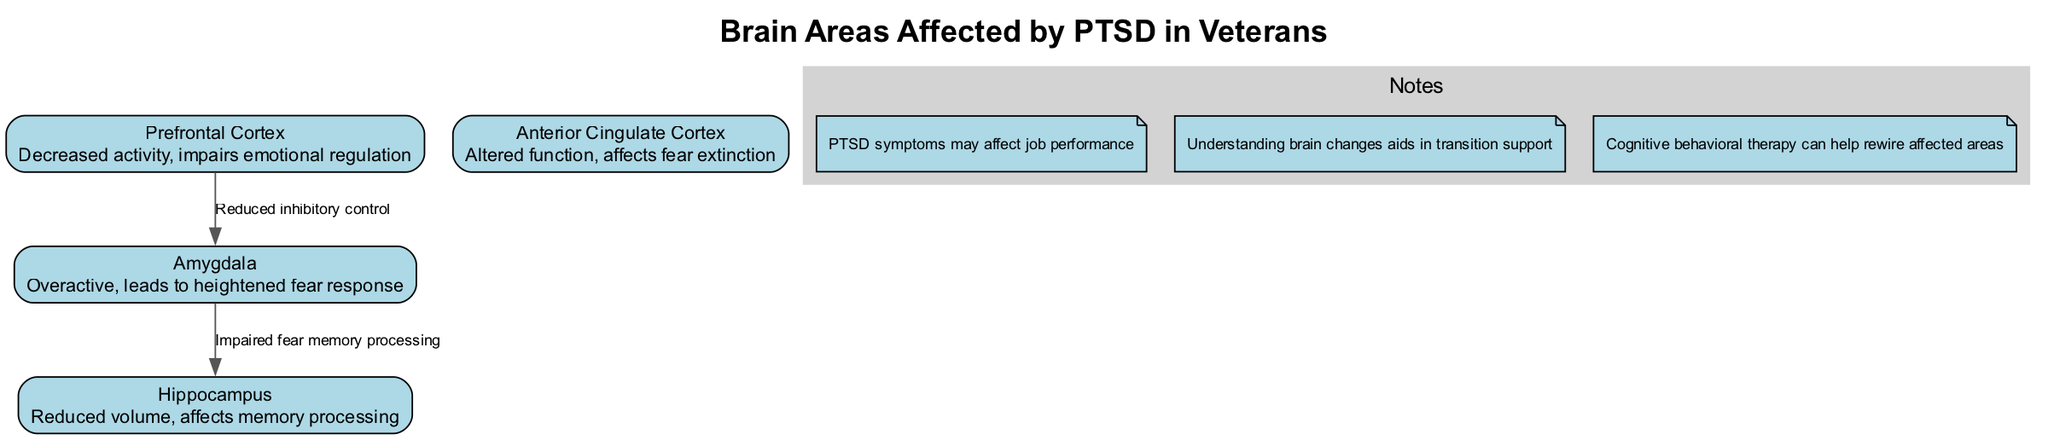What is the primary effect on the Amygdala in PTSD? The diagram specifies that the Amygdala is "Overactive," which indicates that it has increased activity leading to a heightened fear response in individuals with PTSD.
Answer: Overactive How does PTSD affect the Hippocampus? According to the diagram, the Hippocampus has a "Reduced volume," which suggests that its size decreases or diminishes, affecting memory processing in those experiencing PTSD.
Answer: Reduced volume Which brain area has decreased activity in PTSD? The diagram indicates that the "Prefrontal Cortex" has decreased activity, revealing the impairment in emotional regulation due to PTSD.
Answer: Prefrontal Cortex What connection exists between the Amygdala and the Hippocampus? The diagram specifies that the connection is labeled as "Impaired fear memory processing," indicating a direct effect of the Amygdala's overactivity on the functioning of the Hippocampus in PTSD.
Answer: Impaired fear memory processing How many main components are highlighted in the diagram? There are four main components listed in the diagram: Amygdala, Hippocampus, Prefrontal Cortex, and Anterior Cingulate Cortex. By counting those components, we find the total is four.
Answer: 4 What role does the Prefrontal Cortex play concerning the Amygdala in PTSD? The connection from the Prefrontal Cortex to the Amygdala is labeled as "Reduced inhibitory control," indicating that the reduced control leads to heightened activity or overactivity in the Amygdala.
Answer: Reduced inhibitory control What is the effect of PTSD on the Anterior Cingulate Cortex? The diagram states that the Anterior Cingulate Cortex has "Altered function," which suggests that PTSD changes how this area of the brain operates, impacting fear extinction processes.
Answer: Altered function How can understanding brain changes help veterans transition? The notes in the diagram indicate that "Understanding brain changes aids in transition support," emphasizing the importance of this knowledge in assisting veterans to navigate their transition into civilian life.
Answer: Understanding brain changes aids in transition support 